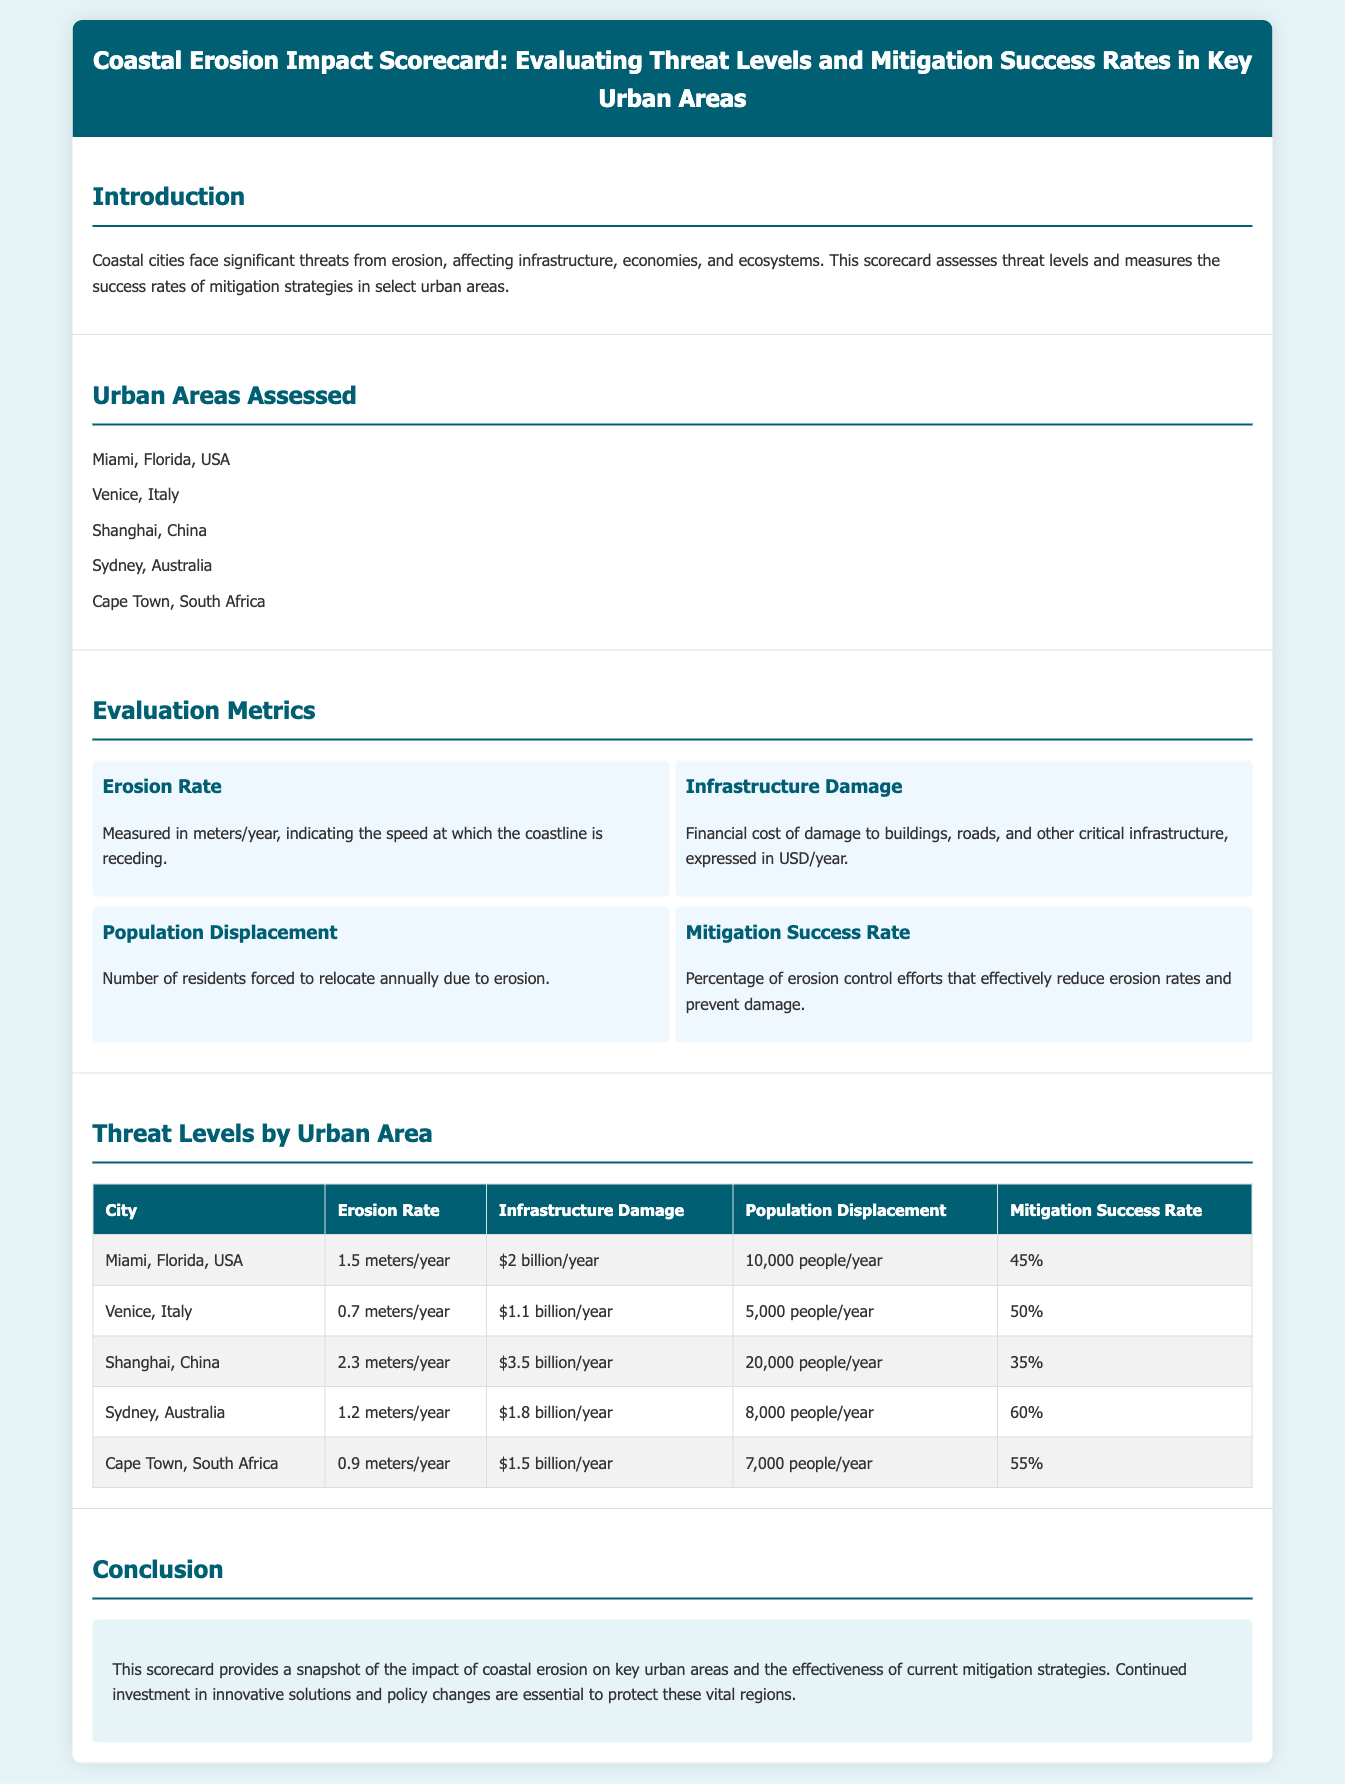What is the erosion rate in Miami? The erosion rate for Miami is mentioned in the table under “Erosion Rate.”
Answer: 1.5 meters/year How much is the infrastructure damage in Shanghai? Infrastructure damage for Shanghai is indicated in the table under “Infrastructure Damage.”
Answer: $3.5 billion/year What is the population displacement in Venice? The document provides the population displacement for Venice in the table under “Population Displacement.”
Answer: 5,000 people/year Which city has the highest mitigation success rate? The highest mitigation success rate can be found by comparing the values listed in the table.
Answer: Sydney, Australia What is the total infrastructure damage for all cities? The total can be calculated by summing the infrastructure damage figures listed for all cities.
Answer: $10.9 billion/year Which city has the lowest erosion rate? The lowest erosion rate can be identified from the comparison in the table.
Answer: Venice, Italy How many people are displaced annually in Cape Town? This information is presented directly in the document under Cape Town’s metrics.
Answer: 7,000 people/year What is the introduction's main concern? The introduction outlines the threat posed by erosion to coastal cities, specifically mentioning infrastructure, economies, and ecosystems.
Answer: Erosion threats What percentage of mitigation efforts are successful in Miami? The table shows the mitigation success rate for Miami clearly.
Answer: 45% 